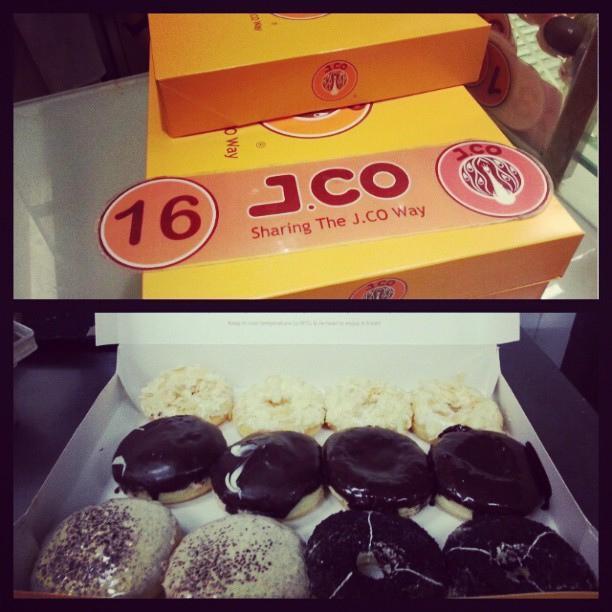How many donuts are in the photo?
Give a very brief answer. 12. 